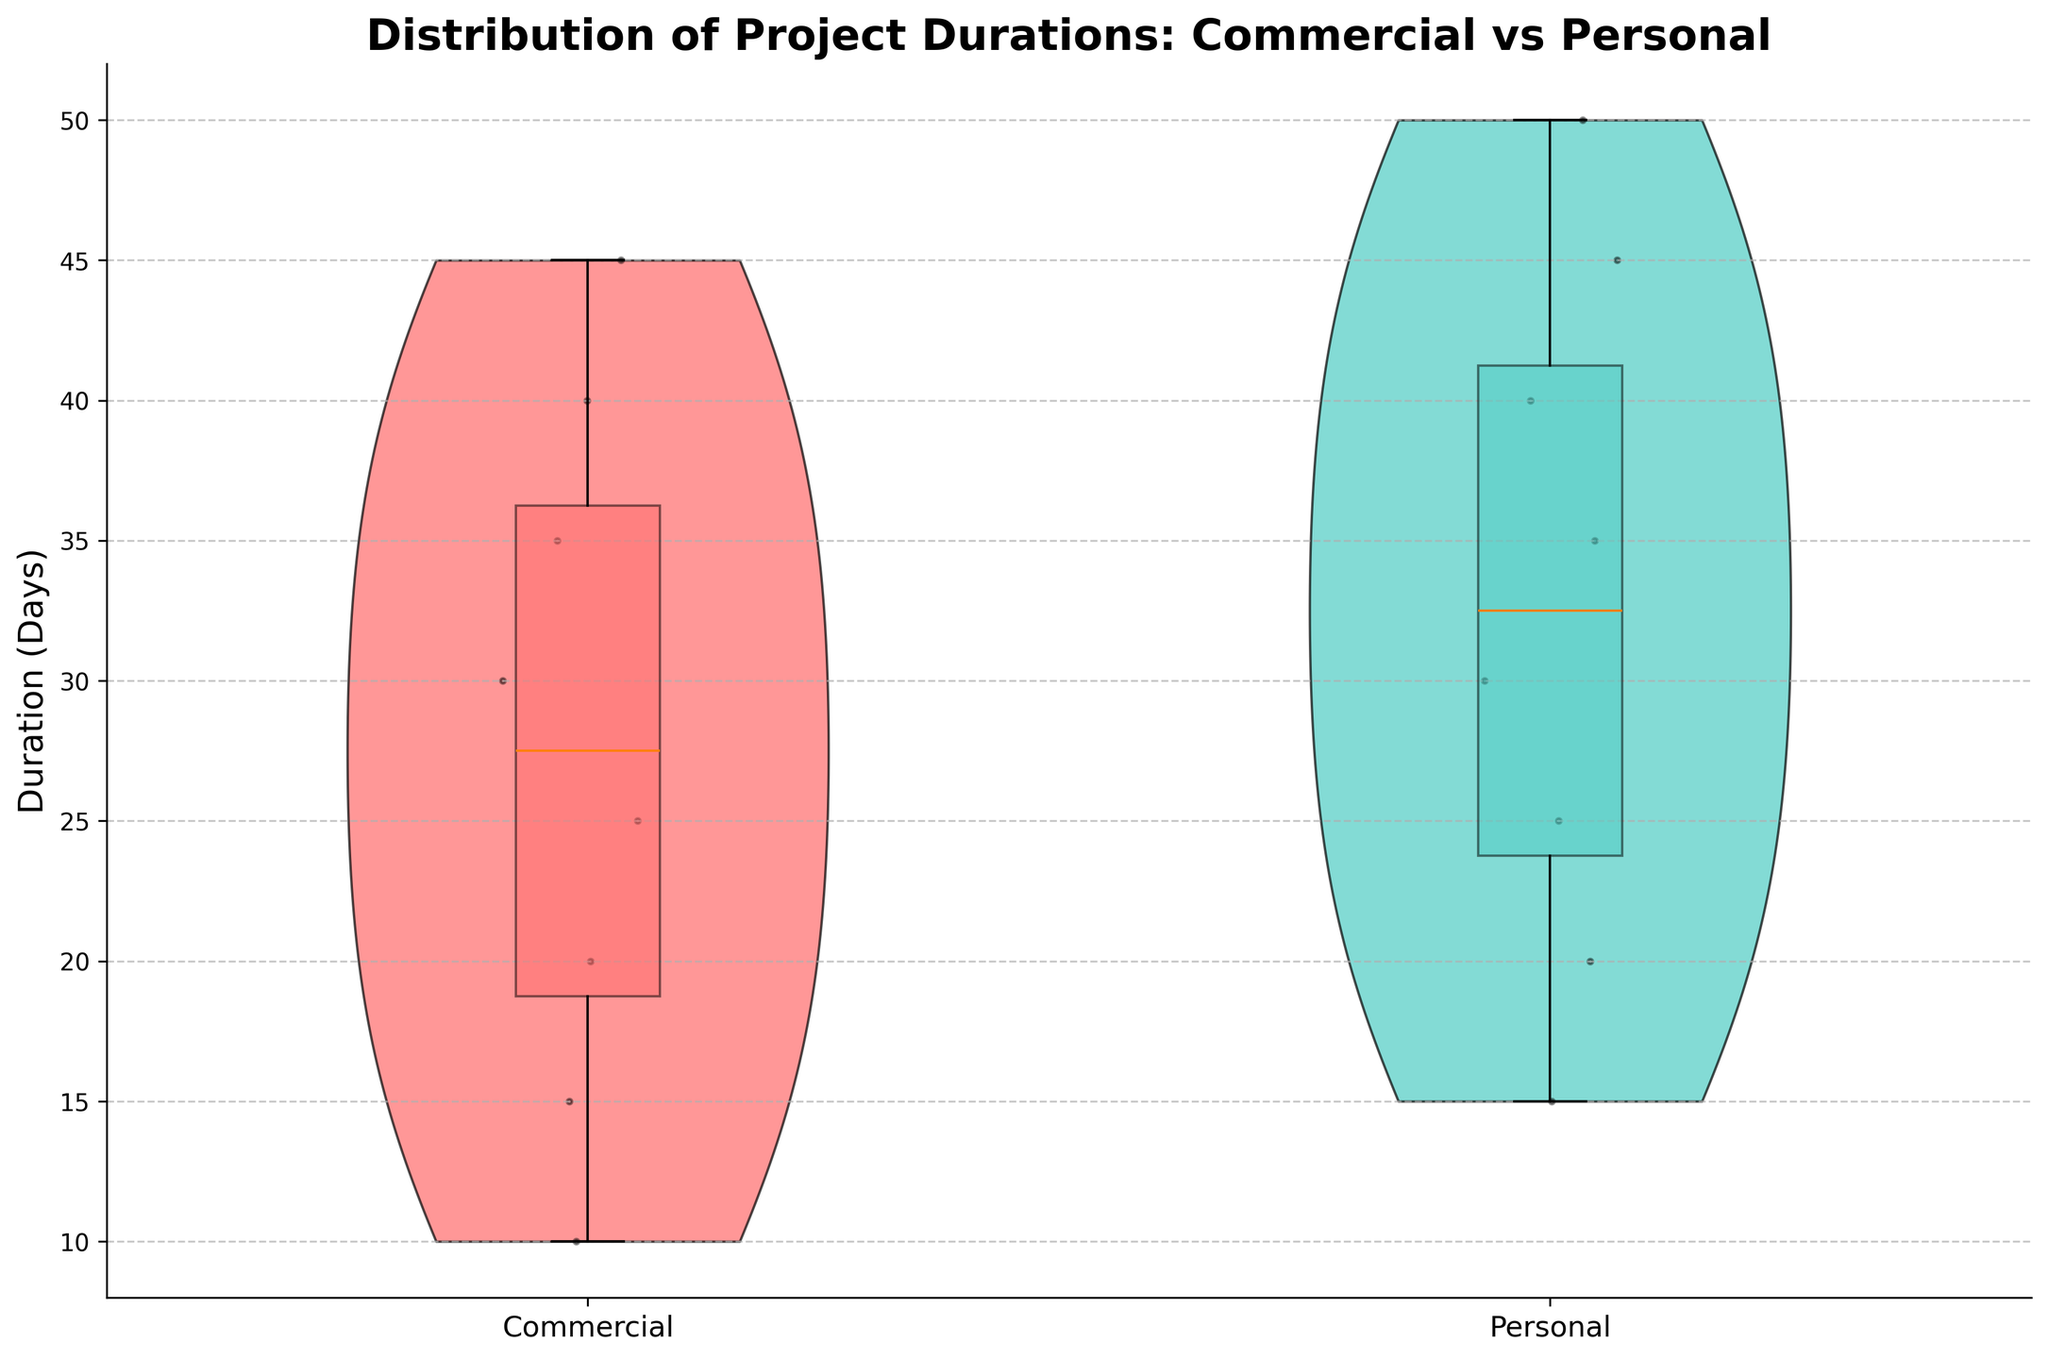1. What is the title of the plot? The title is usually placed at the top of the plot for easy identification. Here, it reads "Distribution of Project Durations: Commercial vs Personal."
Answer: Distribution of Project Durations: Commercial vs Personal 2. What are the two categories compared in the plot? The x-axis labels denote the two categories being compared. In this case, the labels are 'Commercial' and 'Personal.'
Answer: Commercial, Personal 3. Which project type has a higher median duration? The box plot overlay shows the median with a line inside each box. By comparing the medians, we can see that 'Personal' projects have a higher median duration than 'Commercial' projects.
Answer: Personal 4. What are the colors used for Commercial and Personal project types in the violin plot? By observing the color of the violins, we can notice that 'Commercial' projects are colored in a red shade, and 'Personal' projects are colored in a teal shade.
Answer: Red (Commercial), Teal (Personal) 5. Are outliers represented in the plot? Typically, outliers are marked with distinct points outside the whisker range in a box plot. In this figure, there are no individual markers indicating outliers.
Answer: No 6. How does the spread of project durations for Commercial projects compare to Personal projects? Looking at the width of the violin plots, 'Commercial' projects show a tighter, more concentrated distribution compared to the wider spread of 'Personal' projects, which indicates more variability in their durations.
Answer: More variable (Personal) 7. What is the approximate interquartile range (IQR) for Personal projects? The IQR is the range between the first quartile (Q1) and the third quartile (Q3) in the box plots. For Personal projects, these appear to lie roughly between 20 days and 40 days. The IQR is thus 40 - 20 = 20 days.
Answer: 20 days 8. Do any Commercial projects have durations shorter than 10 days? We can analyze the lower end of the Commercial violin plot and the box plot. The shortest duration for Commercial projects is represented around 10 days, with no points below this value.
Answer: No 9. What is the range of durations for Personal projects, from minimum to maximum? Observing the data distribution in the violin plot and box plot for Personal projects, the minimum duration appears to be around 15 days, and the maximum is around 50 days.
Answer: 15 to 50 days 10. Which type of project has more data points? By counting the number of scatter points within each violin plot, it appears that both categories have the same number of data points, with 8 projects each.
Answer: Equal 